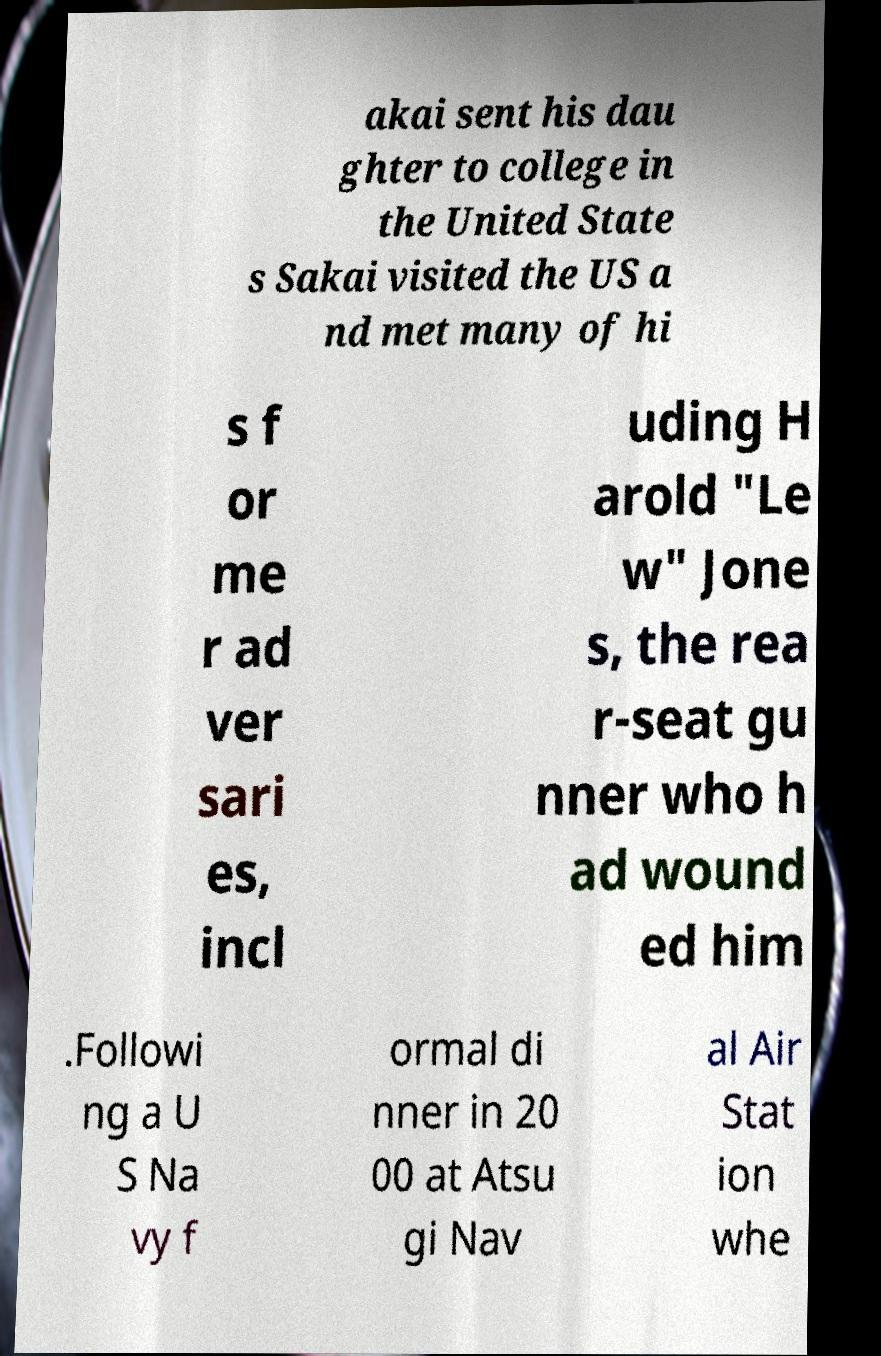I need the written content from this picture converted into text. Can you do that? akai sent his dau ghter to college in the United State s Sakai visited the US a nd met many of hi s f or me r ad ver sari es, incl uding H arold "Le w" Jone s, the rea r-seat gu nner who h ad wound ed him .Followi ng a U S Na vy f ormal di nner in 20 00 at Atsu gi Nav al Air Stat ion whe 